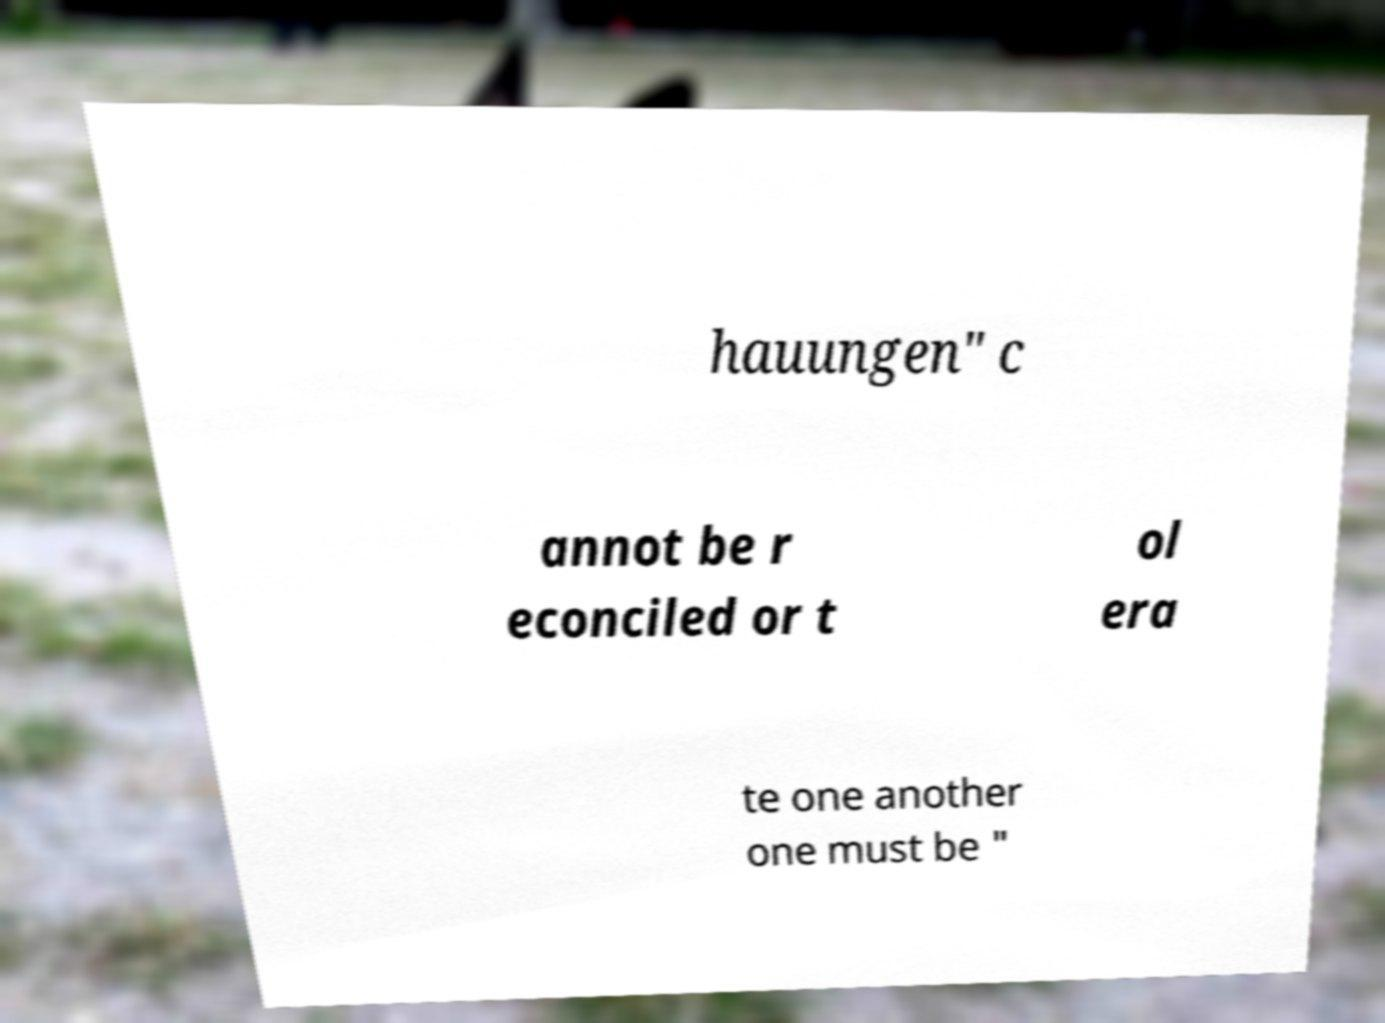Can you read and provide the text displayed in the image?This photo seems to have some interesting text. Can you extract and type it out for me? hauungen" c annot be r econciled or t ol era te one another one must be " 